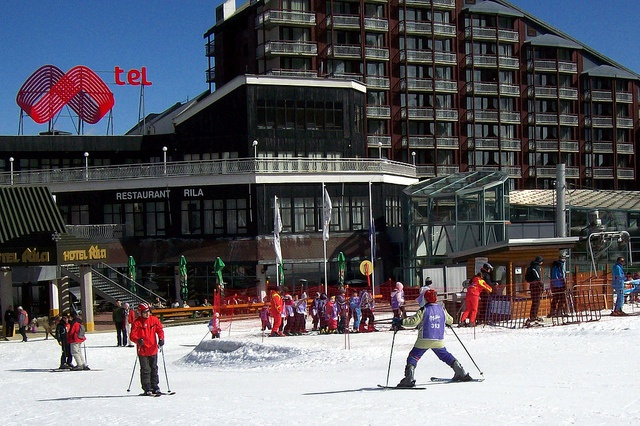Describe the objects in this image and their specific colors. I can see people in blue, black, maroon, gray, and lightgray tones, people in blue, gray, black, and navy tones, people in blue, black, brown, red, and maroon tones, people in blue, white, black, gray, and darkgray tones, and people in blue, black, navy, maroon, and gray tones in this image. 